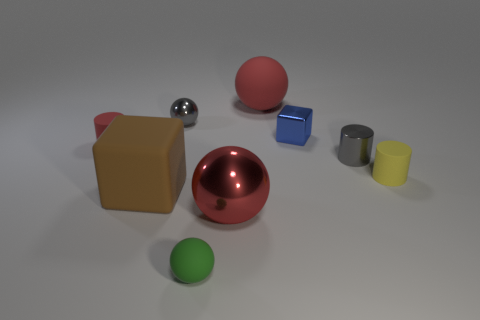Are there any other things that are made of the same material as the gray ball?
Your answer should be compact. Yes. There is a big red shiny ball; what number of tiny blue blocks are on the left side of it?
Make the answer very short. 0. Are there more tiny green metallic cubes than metallic balls?
Provide a short and direct response. No. The cylinder that is the same color as the large metal thing is what size?
Your response must be concise. Small. What size is the sphere that is in front of the small gray cylinder and behind the green rubber object?
Provide a short and direct response. Large. There is a tiny ball behind the tiny matte cylinder that is right of the big red object behind the small metallic cylinder; what is its material?
Make the answer very short. Metal. What material is the other sphere that is the same color as the large matte sphere?
Your answer should be compact. Metal. Does the small ball that is in front of the small block have the same color as the matte cylinder that is left of the big brown rubber thing?
Keep it short and to the point. No. There is a big matte object behind the yellow rubber cylinder that is to the right of the matte sphere that is on the left side of the big metal sphere; what shape is it?
Provide a short and direct response. Sphere. The small object that is both in front of the tiny gray metal cylinder and behind the red metal ball has what shape?
Provide a short and direct response. Cylinder. 